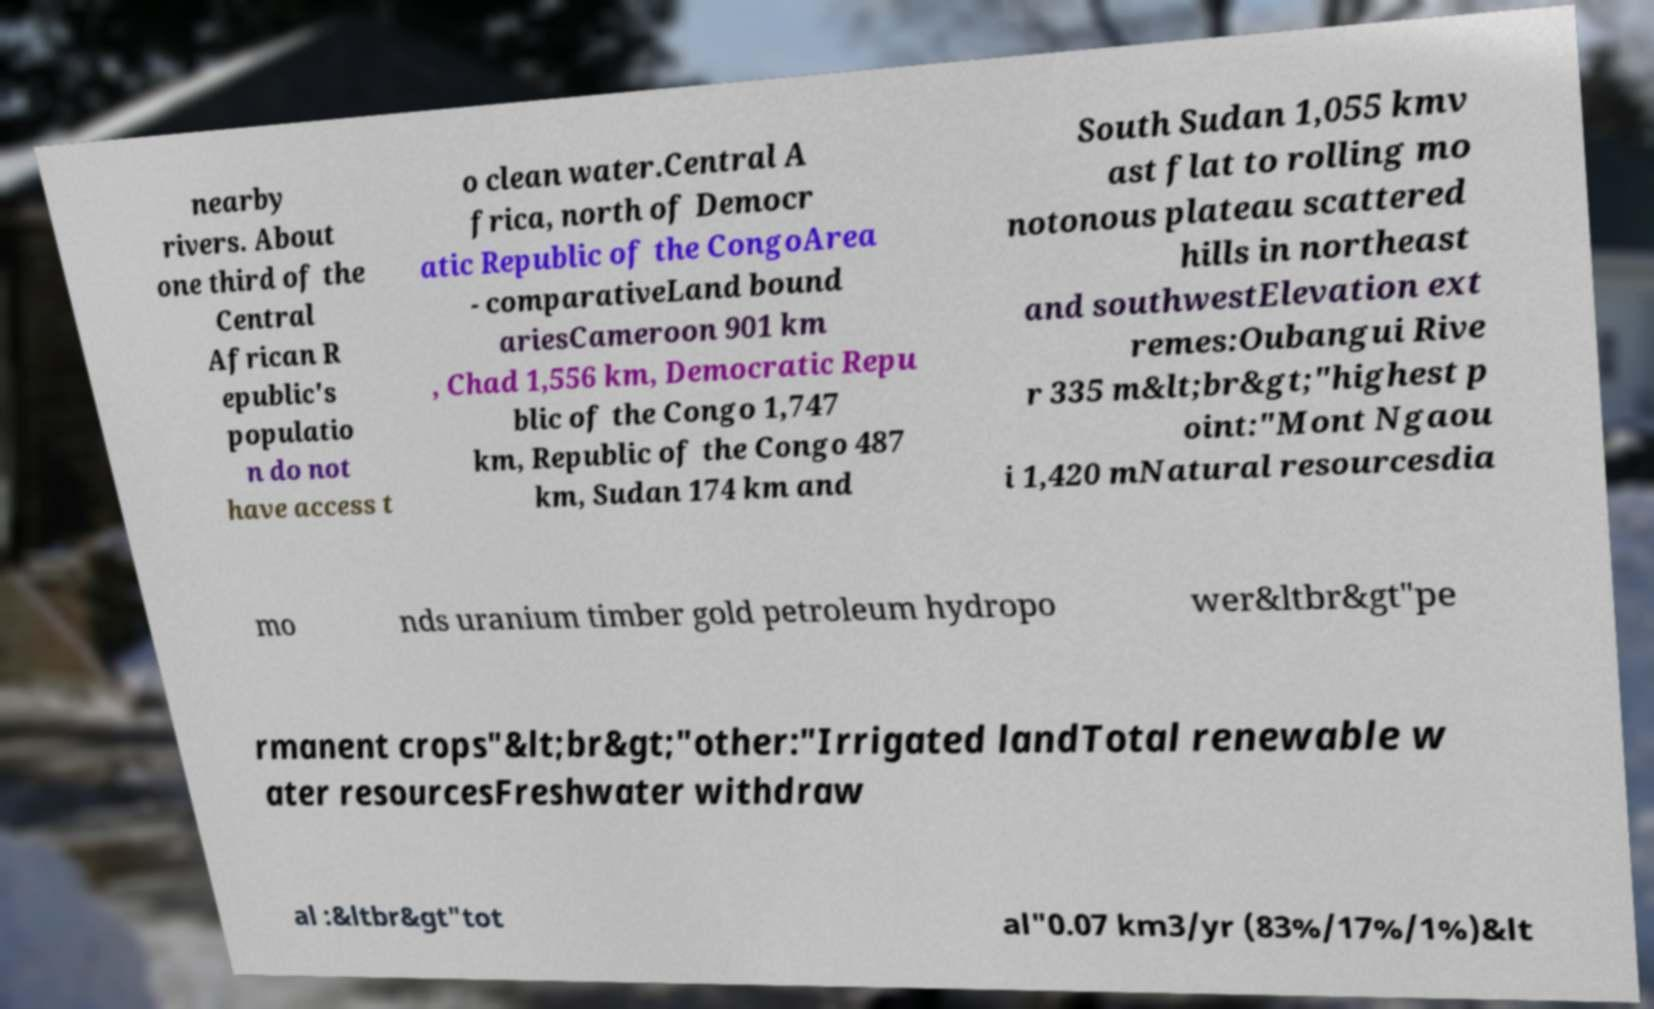Can you read and provide the text displayed in the image?This photo seems to have some interesting text. Can you extract and type it out for me? nearby rivers. About one third of the Central African R epublic's populatio n do not have access t o clean water.Central A frica, north of Democr atic Republic of the CongoArea - comparativeLand bound ariesCameroon 901 km , Chad 1,556 km, Democratic Repu blic of the Congo 1,747 km, Republic of the Congo 487 km, Sudan 174 km and South Sudan 1,055 kmv ast flat to rolling mo notonous plateau scattered hills in northeast and southwestElevation ext remes:Oubangui Rive r 335 m&lt;br&gt;"highest p oint:"Mont Ngaou i 1,420 mNatural resourcesdia mo nds uranium timber gold petroleum hydropo wer&ltbr&gt"pe rmanent crops"&lt;br&gt;"other:"Irrigated landTotal renewable w ater resourcesFreshwater withdraw al :&ltbr&gt"tot al"0.07 km3/yr (83%/17%/1%)&lt 